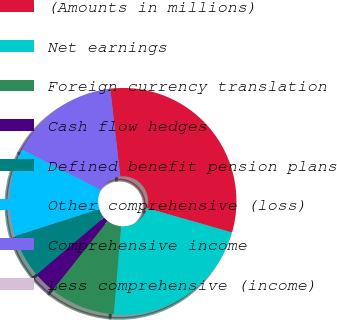Convert chart. <chart><loc_0><loc_0><loc_500><loc_500><pie_chart><fcel>(Amounts in millions)<fcel>Net earnings<fcel>Foreign currency translation<fcel>Cash flow hedges<fcel>Defined benefit pension plans<fcel>Other comprehensive (loss)<fcel>Comprehensive income<fcel>Less comprehensive (income)<nl><fcel>31.25%<fcel>21.87%<fcel>9.38%<fcel>3.13%<fcel>6.25%<fcel>12.5%<fcel>15.62%<fcel>0.0%<nl></chart> 